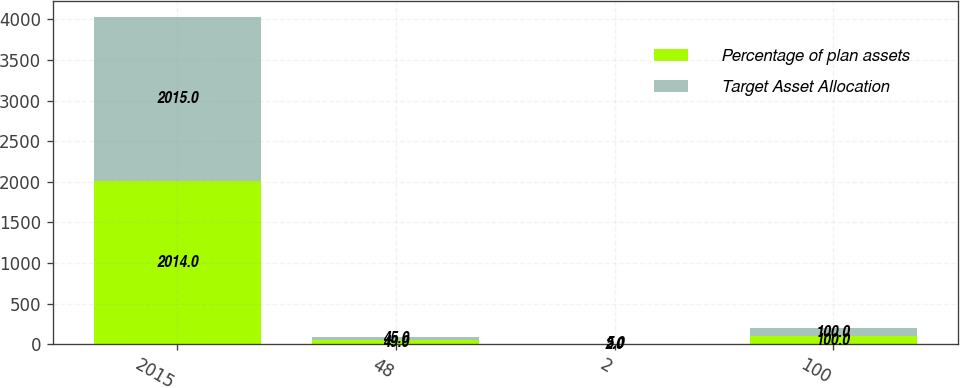Convert chart to OTSL. <chart><loc_0><loc_0><loc_500><loc_500><stacked_bar_chart><ecel><fcel>2015<fcel>48<fcel>2<fcel>100<nl><fcel>Percentage of plan assets<fcel>2014<fcel>49<fcel>2<fcel>100<nl><fcel>Target Asset Allocation<fcel>2015<fcel>45<fcel>5<fcel>100<nl></chart> 